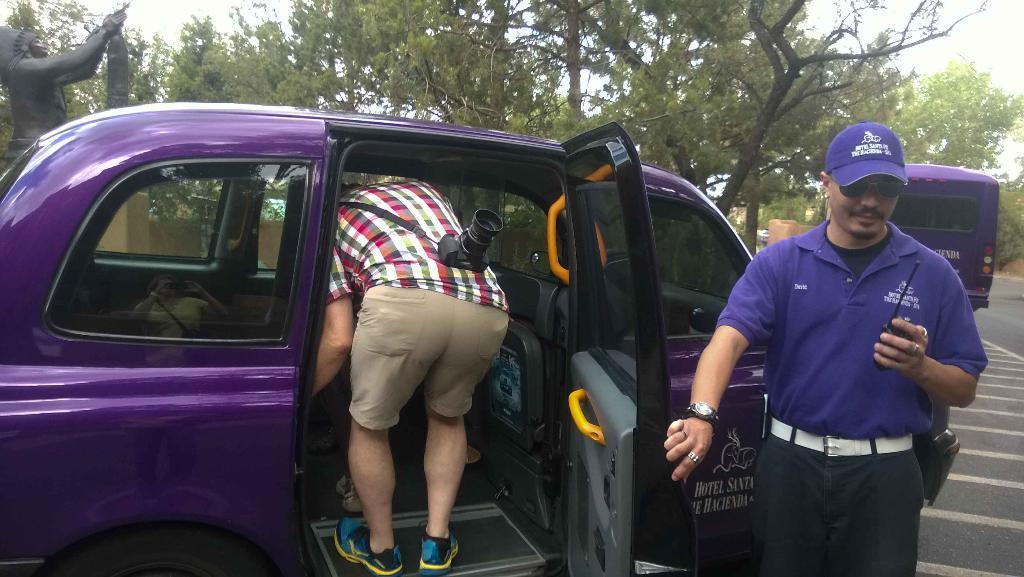Can you describe this image briefly? In this image we can see a car which is on the road. Here we can see a person inside the car and this is a camera. There is a person on the right side. In the background we can see trees, a statue and a van which is on the road. 